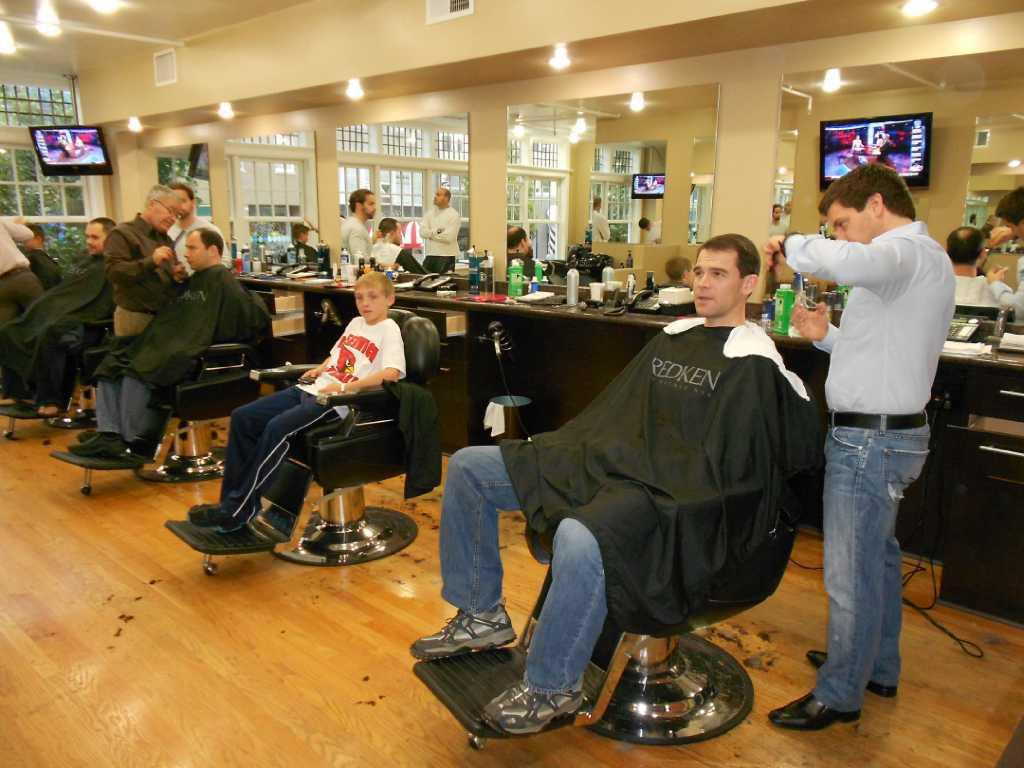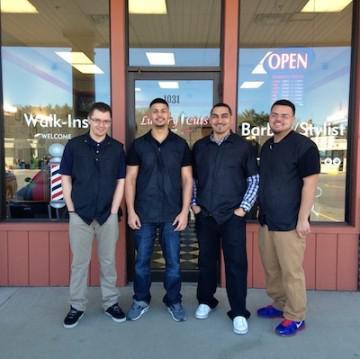The first image is the image on the left, the second image is the image on the right. Assess this claim about the two images: "In at least one image there are four people in black shirts.". Correct or not? Answer yes or no. Yes. The first image is the image on the left, the second image is the image on the right. Given the left and right images, does the statement "In the center of one of the images there is a man with a beard sitting in a barber's chair surrounded by people." hold true? Answer yes or no. No. 